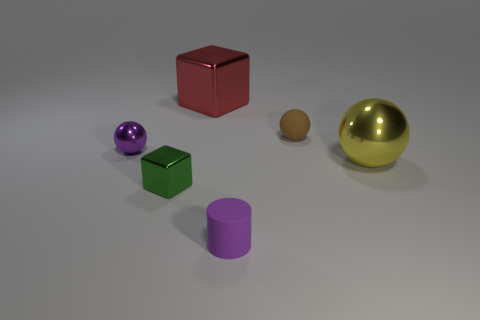What material is the block that is the same size as the purple matte thing?
Give a very brief answer. Metal. Is the material of the yellow sphere the same as the tiny purple sphere?
Offer a very short reply. Yes. There is a small thing that is both on the left side of the small purple matte thing and behind the tiny metal block; what is its color?
Offer a very short reply. Purple. Do the matte object that is behind the big yellow object and the cylinder have the same color?
Make the answer very short. No. There is a red thing that is the same size as the yellow object; what shape is it?
Your response must be concise. Cube. How many other things are the same color as the rubber cylinder?
Provide a short and direct response. 1. How many other objects are there of the same material as the small purple cylinder?
Give a very brief answer. 1. There is a brown thing; does it have the same size as the metallic ball on the right side of the green cube?
Provide a short and direct response. No. The small rubber ball has what color?
Provide a short and direct response. Brown. There is a purple object that is behind the large shiny object that is right of the large shiny thing behind the tiny purple sphere; what shape is it?
Offer a very short reply. Sphere. 